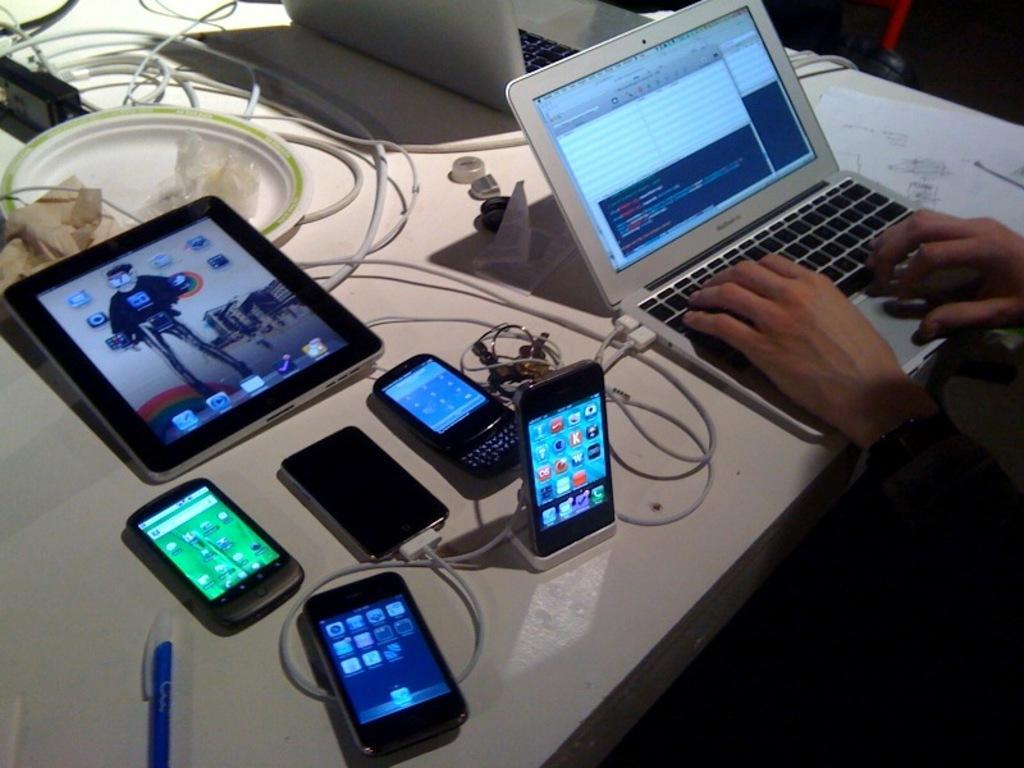Could you give a brief overview of what you see in this image? In the bottom right corner of the image a person is sitting. In the middle of the image we can see a table, on the table there are some mobile phones, laptop, papers, wires and pen. 